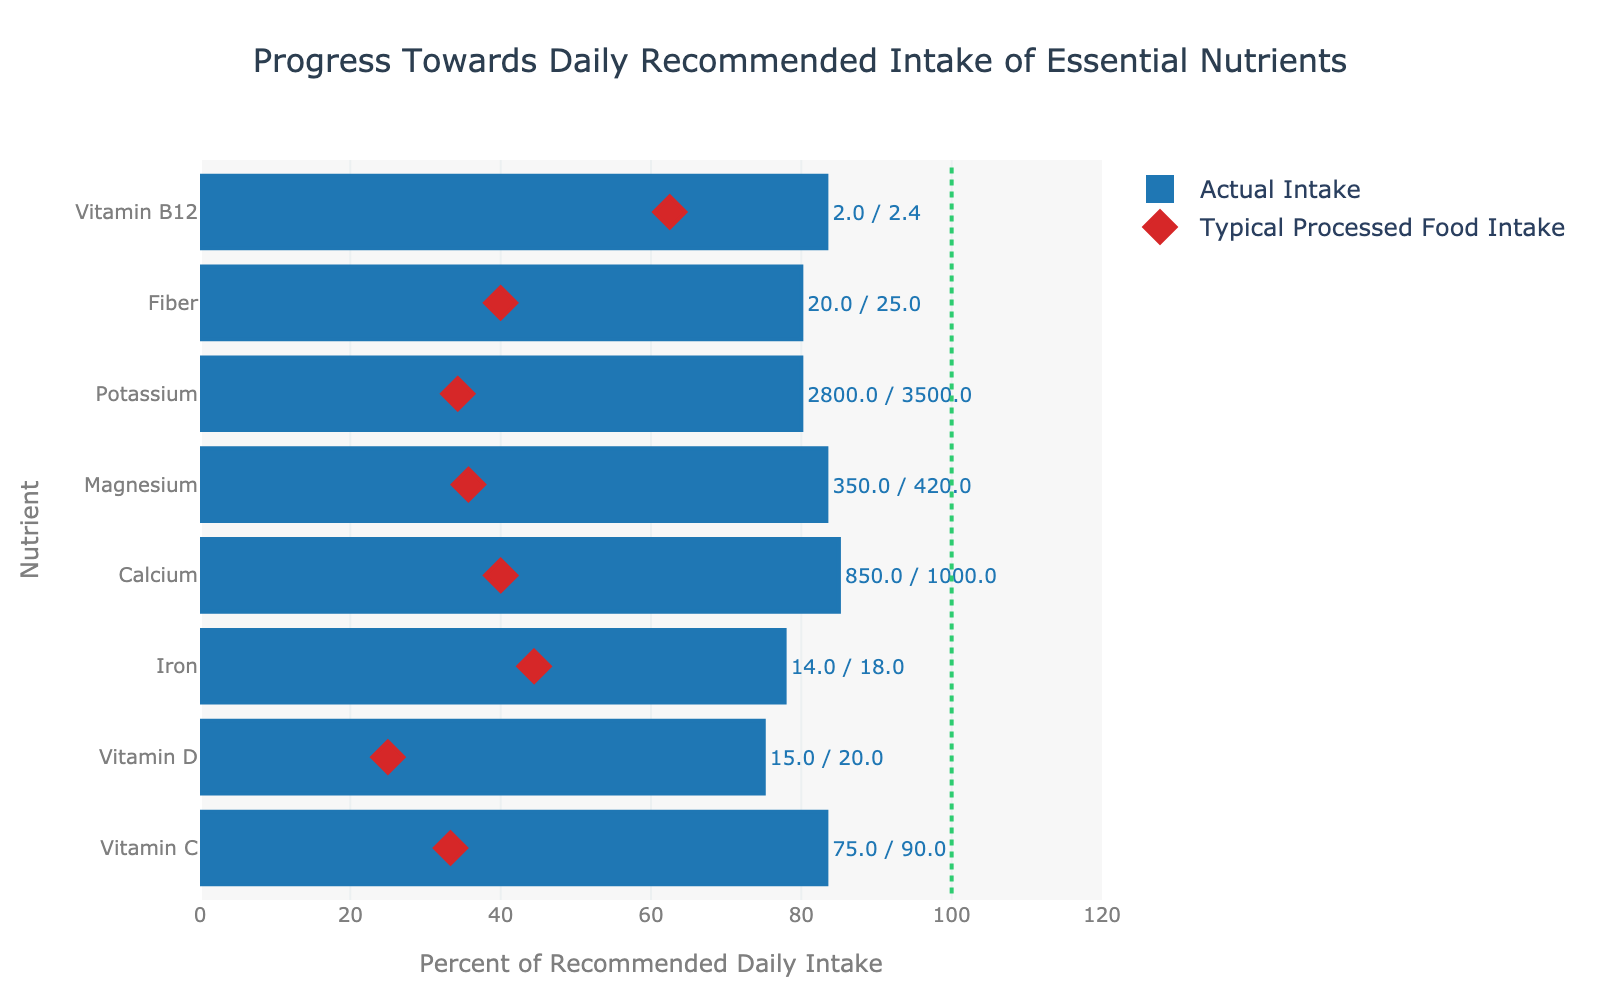What's the title of the figure? The title is located at the top of the figure and usually summarizes the overall purpose or description of the chart.
Answer: Progress Towards Daily Recommended Intake of Essential Nutrients What is the percent of the recommended daily intake for Iron based on actual intake? To find this, you look for the Iron nutrient bar and note the length which represents the percent of the recommended daily intake. The percentage is given as part of the hover information.
Answer: Iron: 77.78% Which nutrient has the lowest percent of recommended daily intake from processed food? To determine this, compare all the diamond markers for each nutrient and identify the one that is closest to the left (0%).
Answer: Vitamin D: 25% How much higher is the actual intake percentage of Magnesium compared to processed food intake percentage? Calculate the difference between the actual intake percentage and processed food intake percentage for Magnesium.
Answer: 50% What nutrient has an actual intake percentage closest to 100% of the recommended daily intake? Identify which bar (actual intake) is closest in length to the 100% vertical line.
Answer: Calcium: 85% Between Vitamin C and Potassium, which nutrient has a greater deficit in percent of actual intake from the recommended intake? Compare the actual intake percentages of both Vitamin C and Potassium to the 100% line and note which one is further from 100%.
Answer: Potassium What is the average actual intake percentage of the vitamins (Vitamin C, Vitamin D, and Vitamin B12)? Add the actual intake percentages of Vitamin C, Vitamin D, and Vitamin B12, then divide by 3.
Answer: 62.22% What is the difference in actual intake between Vitamin D and Calcium? Find the actual intake values of Vitamin D and Calcium and subtract the smaller from the larger.
Answer: 835 - 15 = 835 